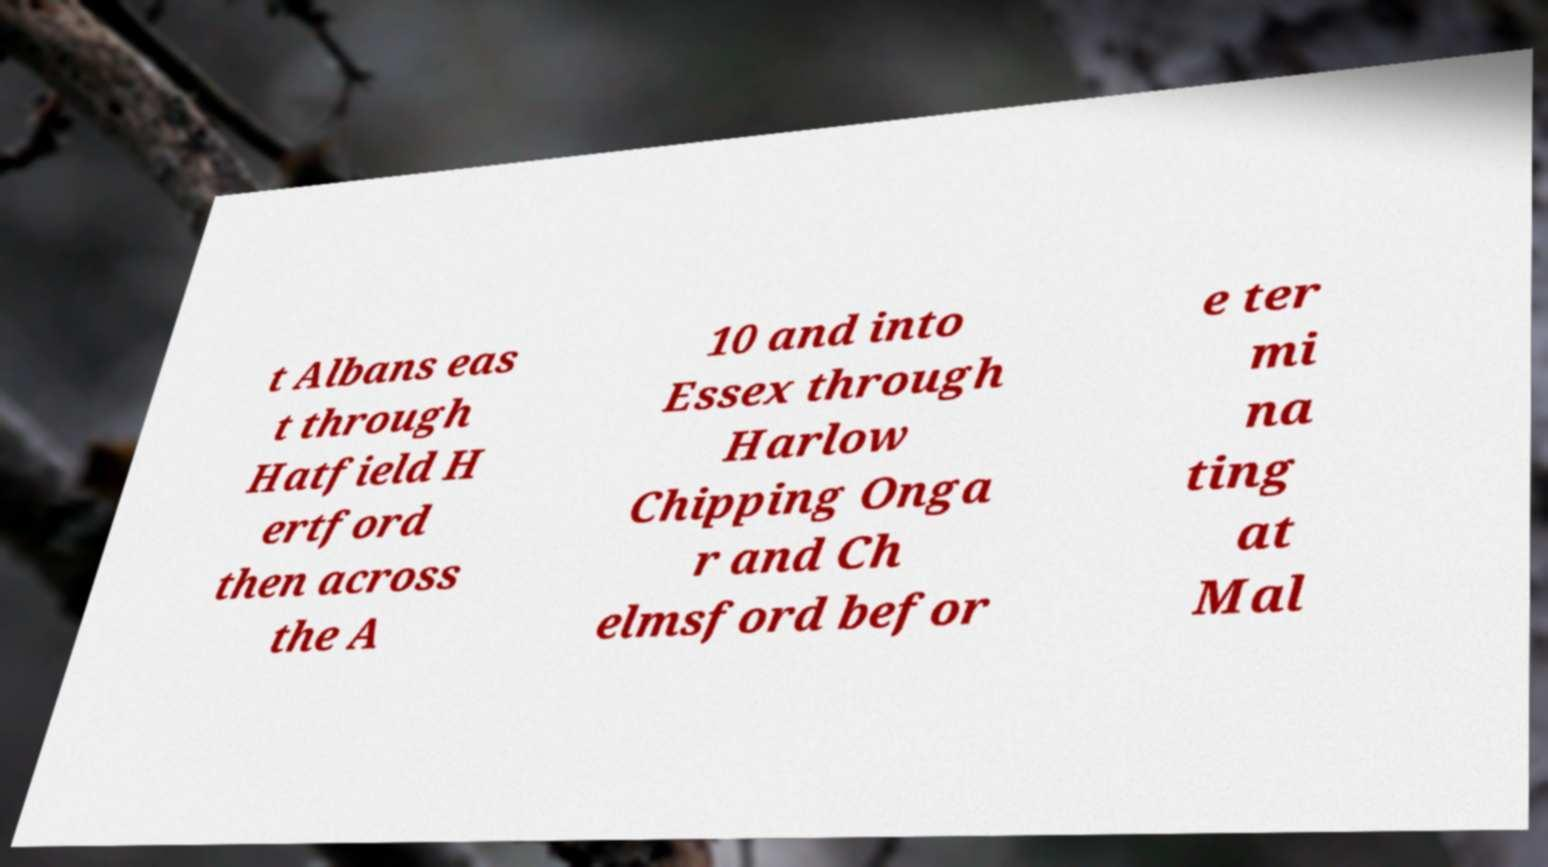Could you assist in decoding the text presented in this image and type it out clearly? t Albans eas t through Hatfield H ertford then across the A 10 and into Essex through Harlow Chipping Onga r and Ch elmsford befor e ter mi na ting at Mal 